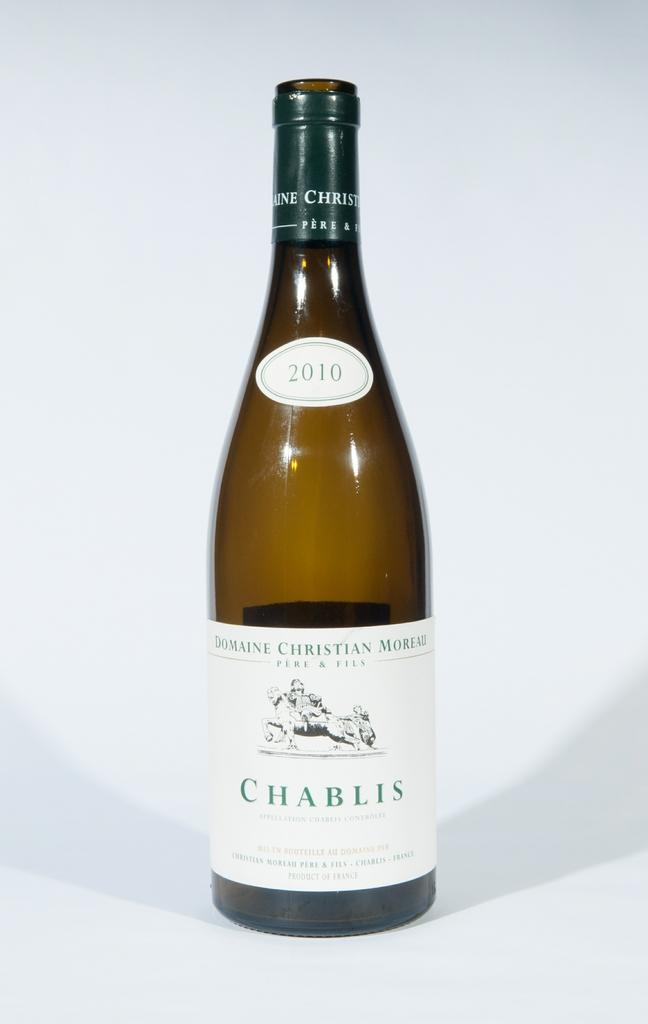Provide a one-sentence caption for the provided image. AN AMBER BOTTLE WITH WHITE LABLE OF CHABLIS 2010 WINE. 